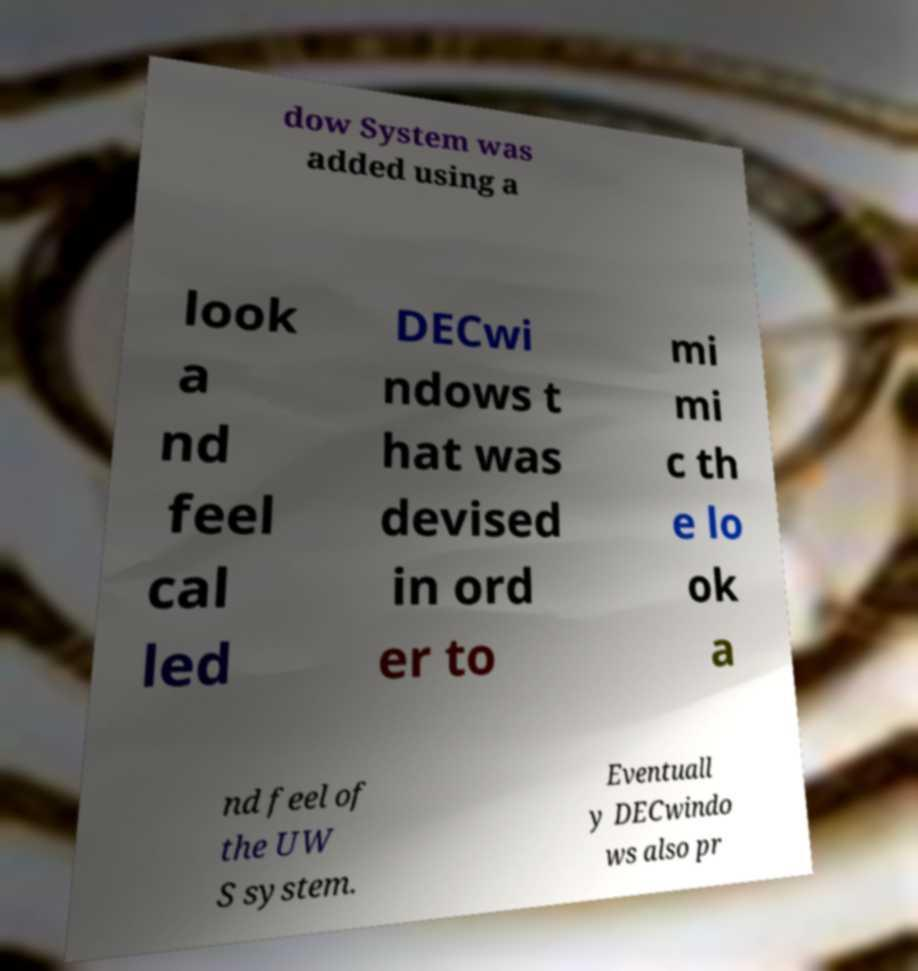Can you accurately transcribe the text from the provided image for me? dow System was added using a look a nd feel cal led DECwi ndows t hat was devised in ord er to mi mi c th e lo ok a nd feel of the UW S system. Eventuall y DECwindo ws also pr 